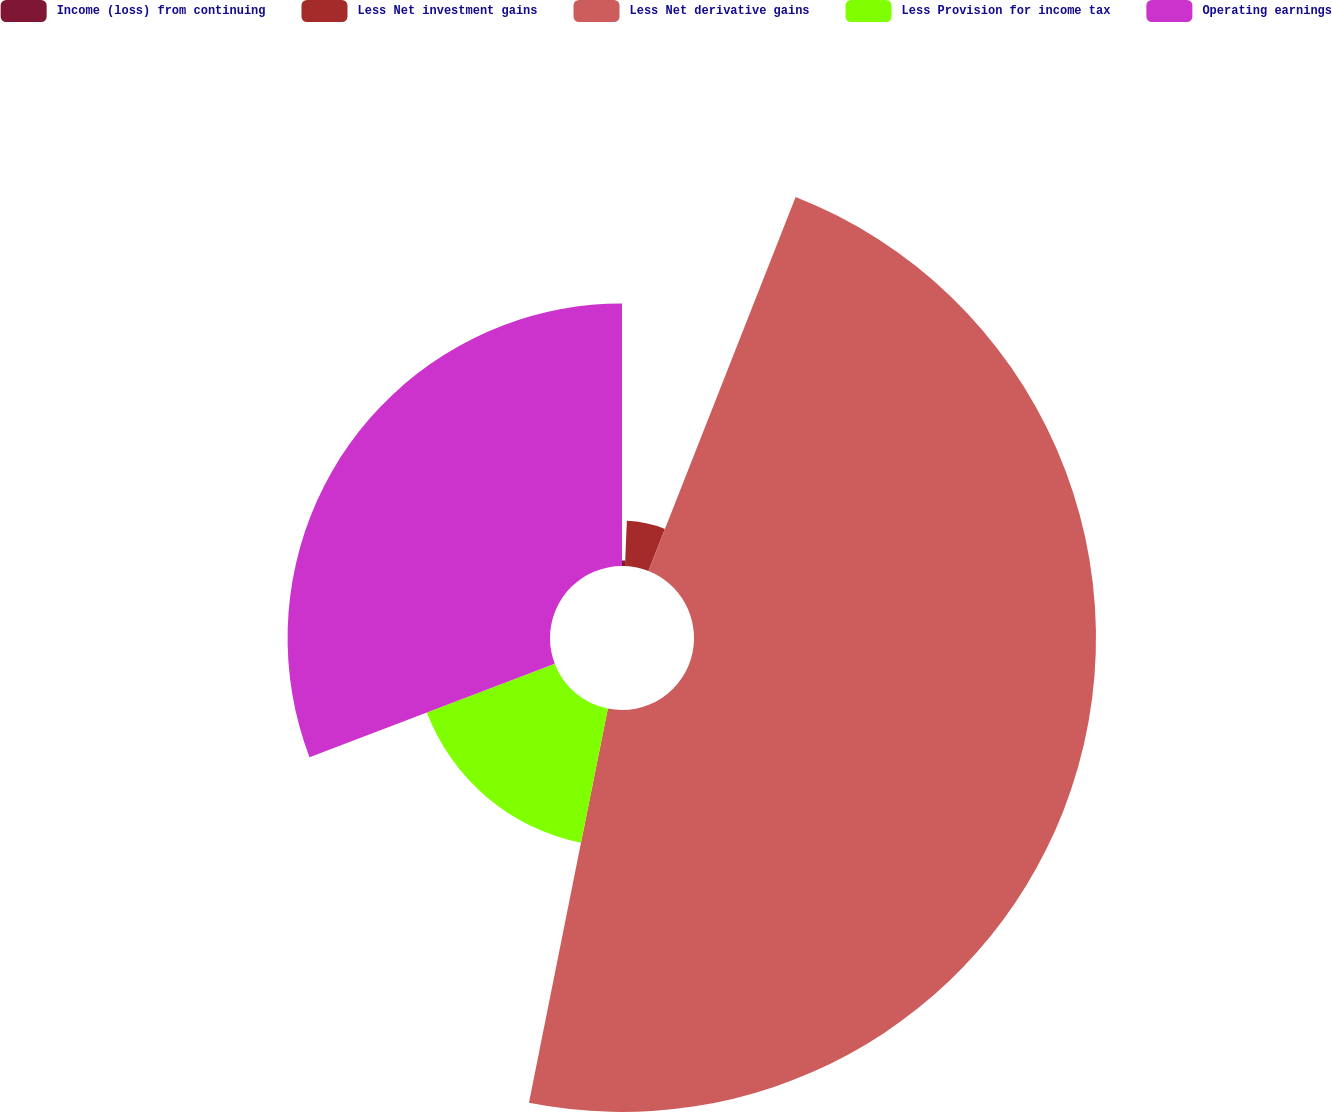Convert chart. <chart><loc_0><loc_0><loc_500><loc_500><pie_chart><fcel>Income (loss) from continuing<fcel>Less Net investment gains<fcel>Less Net derivative gains<fcel>Less Provision for income tax<fcel>Operating earnings<nl><fcel>0.66%<fcel>5.31%<fcel>47.18%<fcel>16.06%<fcel>30.8%<nl></chart> 